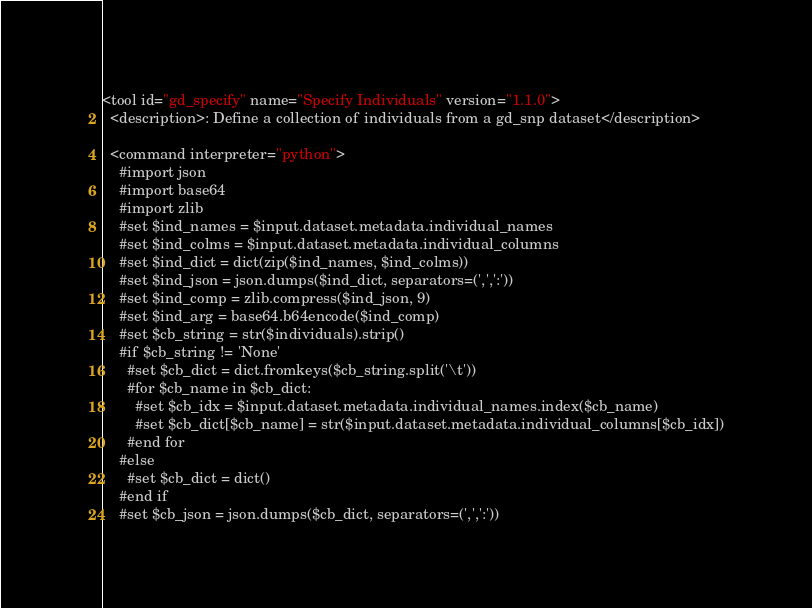<code> <loc_0><loc_0><loc_500><loc_500><_XML_><tool id="gd_specify" name="Specify Individuals" version="1.1.0">
  <description>: Define a collection of individuals from a gd_snp dataset</description>

  <command interpreter="python">
    #import json
    #import base64
    #import zlib
    #set $ind_names = $input.dataset.metadata.individual_names
    #set $ind_colms = $input.dataset.metadata.individual_columns
    #set $ind_dict = dict(zip($ind_names, $ind_colms))
    #set $ind_json = json.dumps($ind_dict, separators=(',',':'))
    #set $ind_comp = zlib.compress($ind_json, 9)
    #set $ind_arg = base64.b64encode($ind_comp)
    #set $cb_string = str($individuals).strip()
    #if $cb_string != 'None'
      #set $cb_dict = dict.fromkeys($cb_string.split('\t'))
      #for $cb_name in $cb_dict:
        #set $cb_idx = $input.dataset.metadata.individual_names.index($cb_name)
        #set $cb_dict[$cb_name] = str($input.dataset.metadata.individual_columns[$cb_idx])
      #end for
    #else
      #set $cb_dict = dict()
    #end if
    #set $cb_json = json.dumps($cb_dict, separators=(',',':'))</code> 